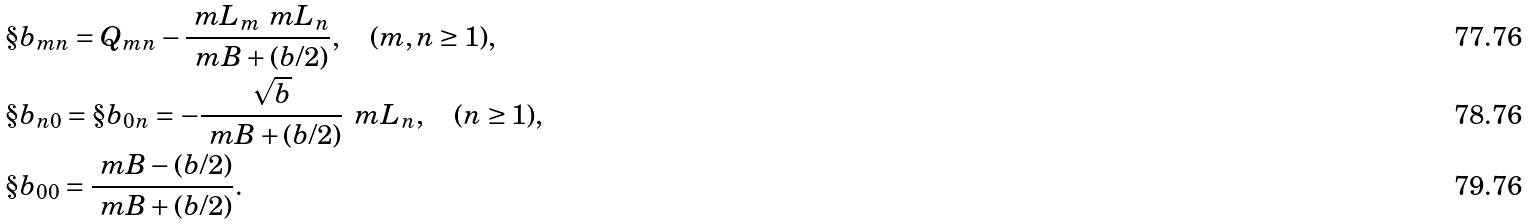Convert formula to latex. <formula><loc_0><loc_0><loc_500><loc_500>& \S b _ { m n } = Q _ { m n } - \frac { \ m L _ { m } \ m L _ { n } } { \ m B + ( b / 2 ) } , \quad ( m , n \geq 1 ) , \\ & \S b _ { n 0 } = \S b _ { 0 n } = - \frac { \sqrt { b } } { \ m B + ( b / 2 ) } \, \ m L _ { n } , \quad ( n \geq 1 ) , \\ & \S b _ { 0 0 } = \frac { \ m B - ( b / 2 ) } { \ m B + ( b / 2 ) } .</formula> 